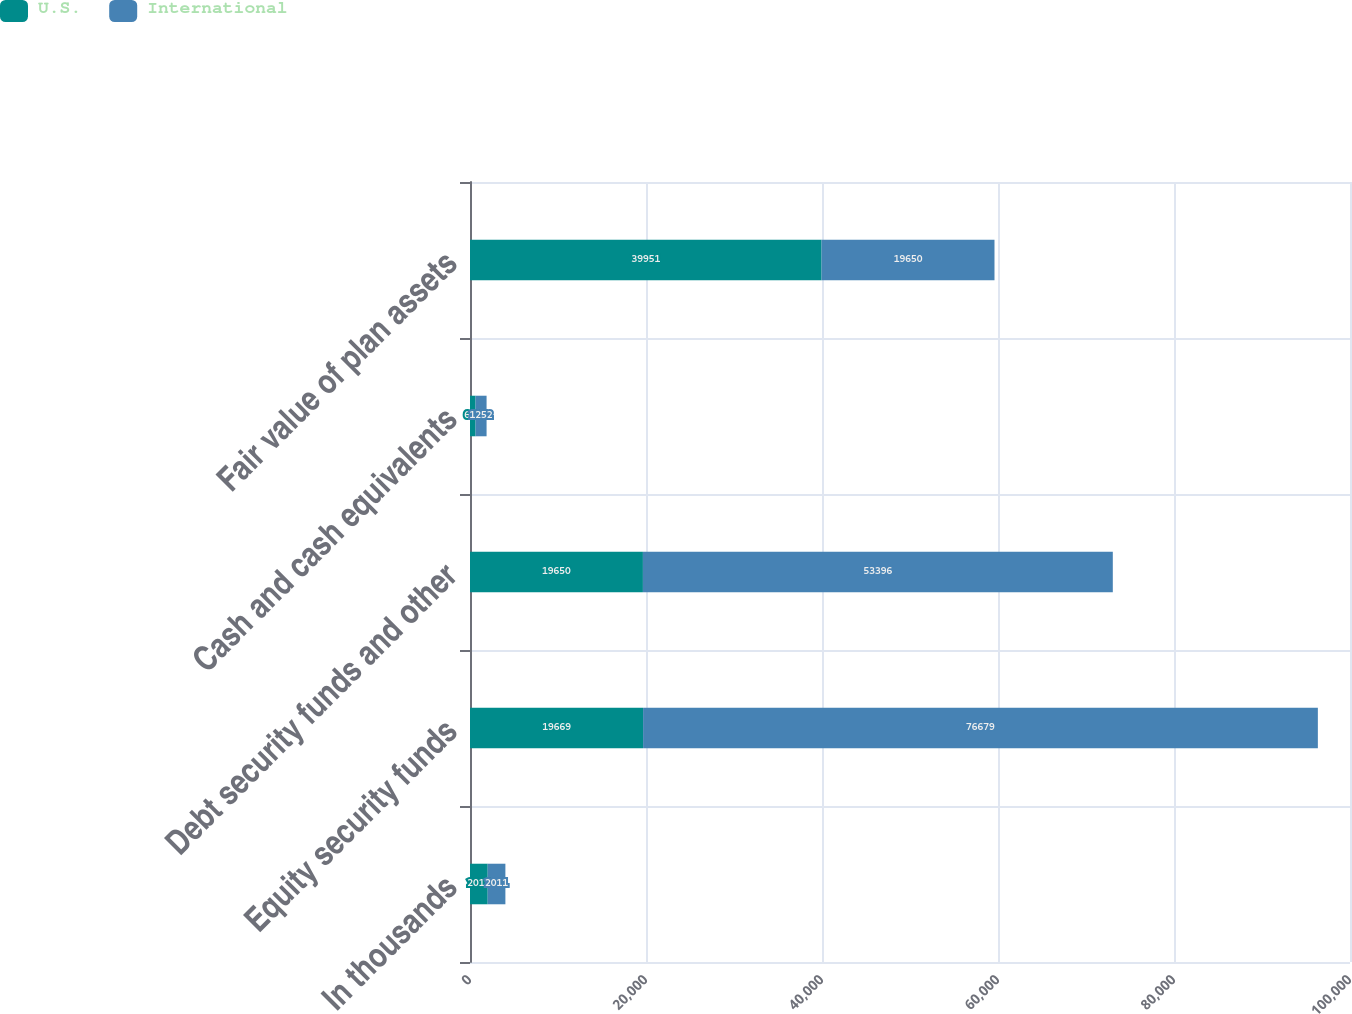Convert chart. <chart><loc_0><loc_0><loc_500><loc_500><stacked_bar_chart><ecel><fcel>In thousands<fcel>Equity security funds<fcel>Debt security funds and other<fcel>Cash and cash equivalents<fcel>Fair value of plan assets<nl><fcel>U.S.<fcel>2011<fcel>19669<fcel>19650<fcel>632<fcel>39951<nl><fcel>International<fcel>2011<fcel>76679<fcel>53396<fcel>1252<fcel>19650<nl></chart> 